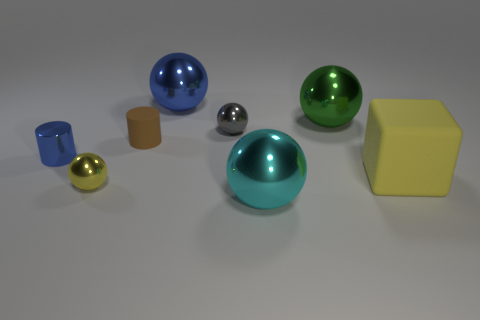Are there more metal things behind the large yellow rubber cube than small brown objects behind the gray metallic ball?
Provide a succinct answer. Yes. Does the large matte cube have the same color as the tiny metallic thing that is in front of the tiny blue metal object?
Ensure brevity in your answer.  Yes. There is a yellow ball that is the same size as the gray metal thing; what is it made of?
Give a very brief answer. Metal. How many objects are tiny yellow objects or balls on the left side of the green metal object?
Your answer should be very brief. 4. Does the gray ball have the same size as the thing on the right side of the green object?
Your answer should be very brief. No. How many cylinders are blue shiny things or green metal objects?
Offer a very short reply. 1. What number of things are to the right of the blue sphere and in front of the gray shiny object?
Your answer should be very brief. 2. How many other objects are the same color as the big block?
Give a very brief answer. 1. There is a rubber thing that is on the left side of the green ball; what shape is it?
Your response must be concise. Cylinder. Is the brown cylinder made of the same material as the tiny blue cylinder?
Your response must be concise. No. 